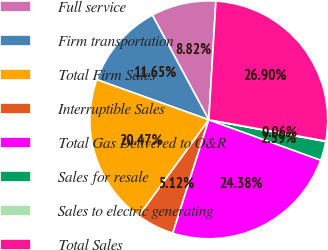<chart> <loc_0><loc_0><loc_500><loc_500><pie_chart><fcel>Full service<fcel>Firm transportation<fcel>Total Firm Sales<fcel>Interruptible Sales<fcel>Total Gas Delivered to O&R<fcel>Sales for resale<fcel>Sales to electric generating<fcel>Total Sales<nl><fcel>8.82%<fcel>11.65%<fcel>20.47%<fcel>5.12%<fcel>24.38%<fcel>2.59%<fcel>0.06%<fcel>26.9%<nl></chart> 